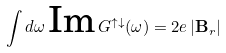Convert formula to latex. <formula><loc_0><loc_0><loc_500><loc_500>\int d \omega \, \text {Im} \, G ^ { \uparrow \downarrow } ( \omega ) = 2 e \, | \mathbf B _ { r } |</formula> 